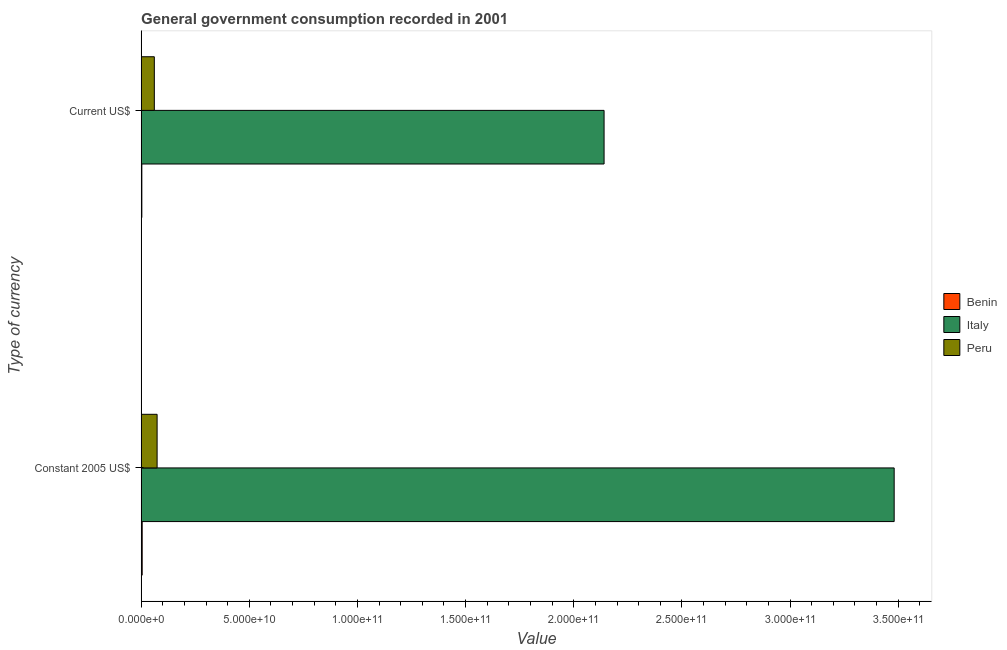How many groups of bars are there?
Keep it short and to the point. 2. Are the number of bars per tick equal to the number of legend labels?
Your answer should be compact. Yes. Are the number of bars on each tick of the Y-axis equal?
Your answer should be very brief. Yes. How many bars are there on the 1st tick from the top?
Give a very brief answer. 3. What is the label of the 1st group of bars from the top?
Make the answer very short. Current US$. What is the value consumed in constant 2005 us$ in Peru?
Your response must be concise. 7.38e+09. Across all countries, what is the maximum value consumed in current us$?
Keep it short and to the point. 2.14e+11. Across all countries, what is the minimum value consumed in constant 2005 us$?
Make the answer very short. 4.81e+08. In which country was the value consumed in constant 2005 us$ maximum?
Your answer should be very brief. Italy. In which country was the value consumed in constant 2005 us$ minimum?
Offer a very short reply. Benin. What is the total value consumed in current us$ in the graph?
Your answer should be compact. 2.20e+11. What is the difference between the value consumed in constant 2005 us$ in Benin and that in Peru?
Provide a succinct answer. -6.90e+09. What is the difference between the value consumed in constant 2005 us$ in Peru and the value consumed in current us$ in Italy?
Offer a very short reply. -2.07e+11. What is the average value consumed in current us$ per country?
Offer a terse response. 7.35e+1. What is the difference between the value consumed in constant 2005 us$ and value consumed in current us$ in Italy?
Give a very brief answer. 1.34e+11. What is the ratio of the value consumed in current us$ in Benin to that in Peru?
Your answer should be very brief. 0.05. What does the 2nd bar from the top in Current US$ represents?
Your answer should be compact. Italy. What does the 1st bar from the bottom in Current US$ represents?
Ensure brevity in your answer.  Benin. How many bars are there?
Ensure brevity in your answer.  6. Does the graph contain any zero values?
Your answer should be compact. No. Does the graph contain grids?
Keep it short and to the point. No. How many legend labels are there?
Your response must be concise. 3. How are the legend labels stacked?
Your answer should be very brief. Vertical. What is the title of the graph?
Your answer should be compact. General government consumption recorded in 2001. What is the label or title of the X-axis?
Provide a short and direct response. Value. What is the label or title of the Y-axis?
Keep it short and to the point. Type of currency. What is the Value in Benin in Constant 2005 US$?
Ensure brevity in your answer.  4.81e+08. What is the Value of Italy in Constant 2005 US$?
Provide a succinct answer. 3.48e+11. What is the Value of Peru in Constant 2005 US$?
Provide a succinct answer. 7.38e+09. What is the Value of Benin in Current US$?
Your answer should be very brief. 3.23e+08. What is the Value in Italy in Current US$?
Provide a succinct answer. 2.14e+11. What is the Value of Peru in Current US$?
Offer a very short reply. 6.10e+09. Across all Type of currency, what is the maximum Value of Benin?
Your answer should be compact. 4.81e+08. Across all Type of currency, what is the maximum Value of Italy?
Offer a terse response. 3.48e+11. Across all Type of currency, what is the maximum Value in Peru?
Provide a succinct answer. 7.38e+09. Across all Type of currency, what is the minimum Value in Benin?
Provide a short and direct response. 3.23e+08. Across all Type of currency, what is the minimum Value of Italy?
Your response must be concise. 2.14e+11. Across all Type of currency, what is the minimum Value in Peru?
Keep it short and to the point. 6.10e+09. What is the total Value in Benin in the graph?
Ensure brevity in your answer.  8.03e+08. What is the total Value in Italy in the graph?
Your answer should be very brief. 5.62e+11. What is the total Value in Peru in the graph?
Keep it short and to the point. 1.35e+1. What is the difference between the Value of Benin in Constant 2005 US$ and that in Current US$?
Provide a short and direct response. 1.58e+08. What is the difference between the Value of Italy in Constant 2005 US$ and that in Current US$?
Give a very brief answer. 1.34e+11. What is the difference between the Value in Peru in Constant 2005 US$ and that in Current US$?
Give a very brief answer. 1.28e+09. What is the difference between the Value of Benin in Constant 2005 US$ and the Value of Italy in Current US$?
Provide a succinct answer. -2.14e+11. What is the difference between the Value in Benin in Constant 2005 US$ and the Value in Peru in Current US$?
Make the answer very short. -5.62e+09. What is the difference between the Value in Italy in Constant 2005 US$ and the Value in Peru in Current US$?
Provide a succinct answer. 3.42e+11. What is the average Value in Benin per Type of currency?
Keep it short and to the point. 4.02e+08. What is the average Value of Italy per Type of currency?
Offer a terse response. 2.81e+11. What is the average Value of Peru per Type of currency?
Provide a succinct answer. 6.74e+09. What is the difference between the Value in Benin and Value in Italy in Constant 2005 US$?
Your answer should be compact. -3.48e+11. What is the difference between the Value in Benin and Value in Peru in Constant 2005 US$?
Keep it short and to the point. -6.90e+09. What is the difference between the Value of Italy and Value of Peru in Constant 2005 US$?
Your answer should be very brief. 3.41e+11. What is the difference between the Value of Benin and Value of Italy in Current US$?
Offer a very short reply. -2.14e+11. What is the difference between the Value of Benin and Value of Peru in Current US$?
Your answer should be compact. -5.77e+09. What is the difference between the Value in Italy and Value in Peru in Current US$?
Provide a succinct answer. 2.08e+11. What is the ratio of the Value of Benin in Constant 2005 US$ to that in Current US$?
Give a very brief answer. 1.49. What is the ratio of the Value of Italy in Constant 2005 US$ to that in Current US$?
Ensure brevity in your answer.  1.63. What is the ratio of the Value of Peru in Constant 2005 US$ to that in Current US$?
Provide a succinct answer. 1.21. What is the difference between the highest and the second highest Value in Benin?
Give a very brief answer. 1.58e+08. What is the difference between the highest and the second highest Value of Italy?
Provide a succinct answer. 1.34e+11. What is the difference between the highest and the second highest Value in Peru?
Make the answer very short. 1.28e+09. What is the difference between the highest and the lowest Value in Benin?
Your answer should be compact. 1.58e+08. What is the difference between the highest and the lowest Value in Italy?
Provide a succinct answer. 1.34e+11. What is the difference between the highest and the lowest Value in Peru?
Provide a short and direct response. 1.28e+09. 